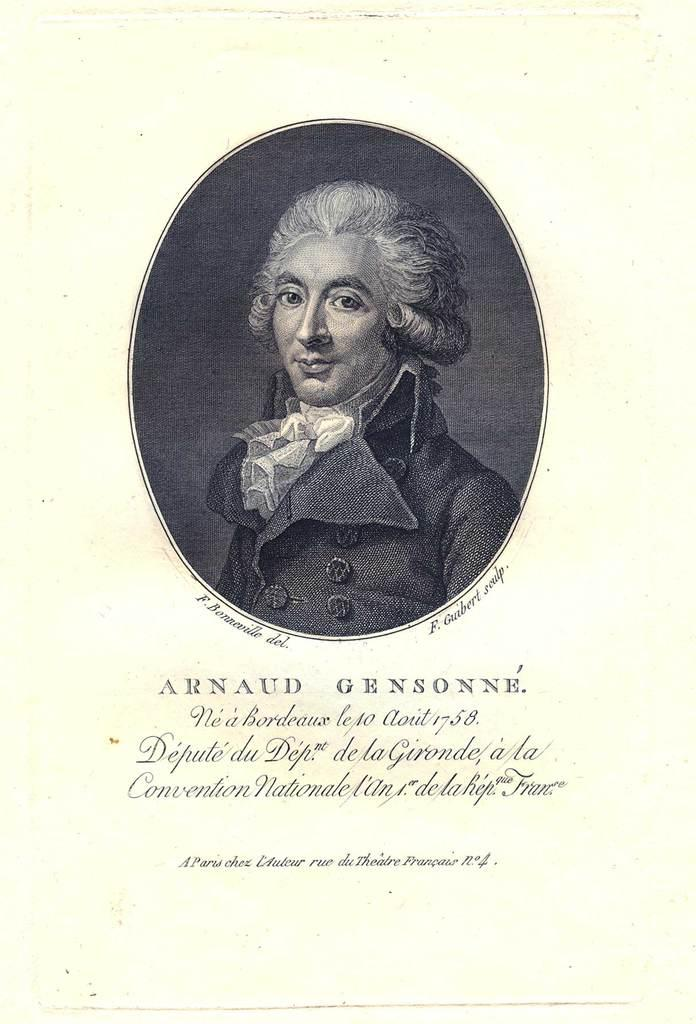What is the main subject of the image? The main subject of the image is a black and white photograph of a man. What is located below the photograph? There is text below the photograph on a paper. How many chickens are visible in the image? There are no chickens present in the image. What is the temperature of the sun in the image? There is no sun present in the image. 